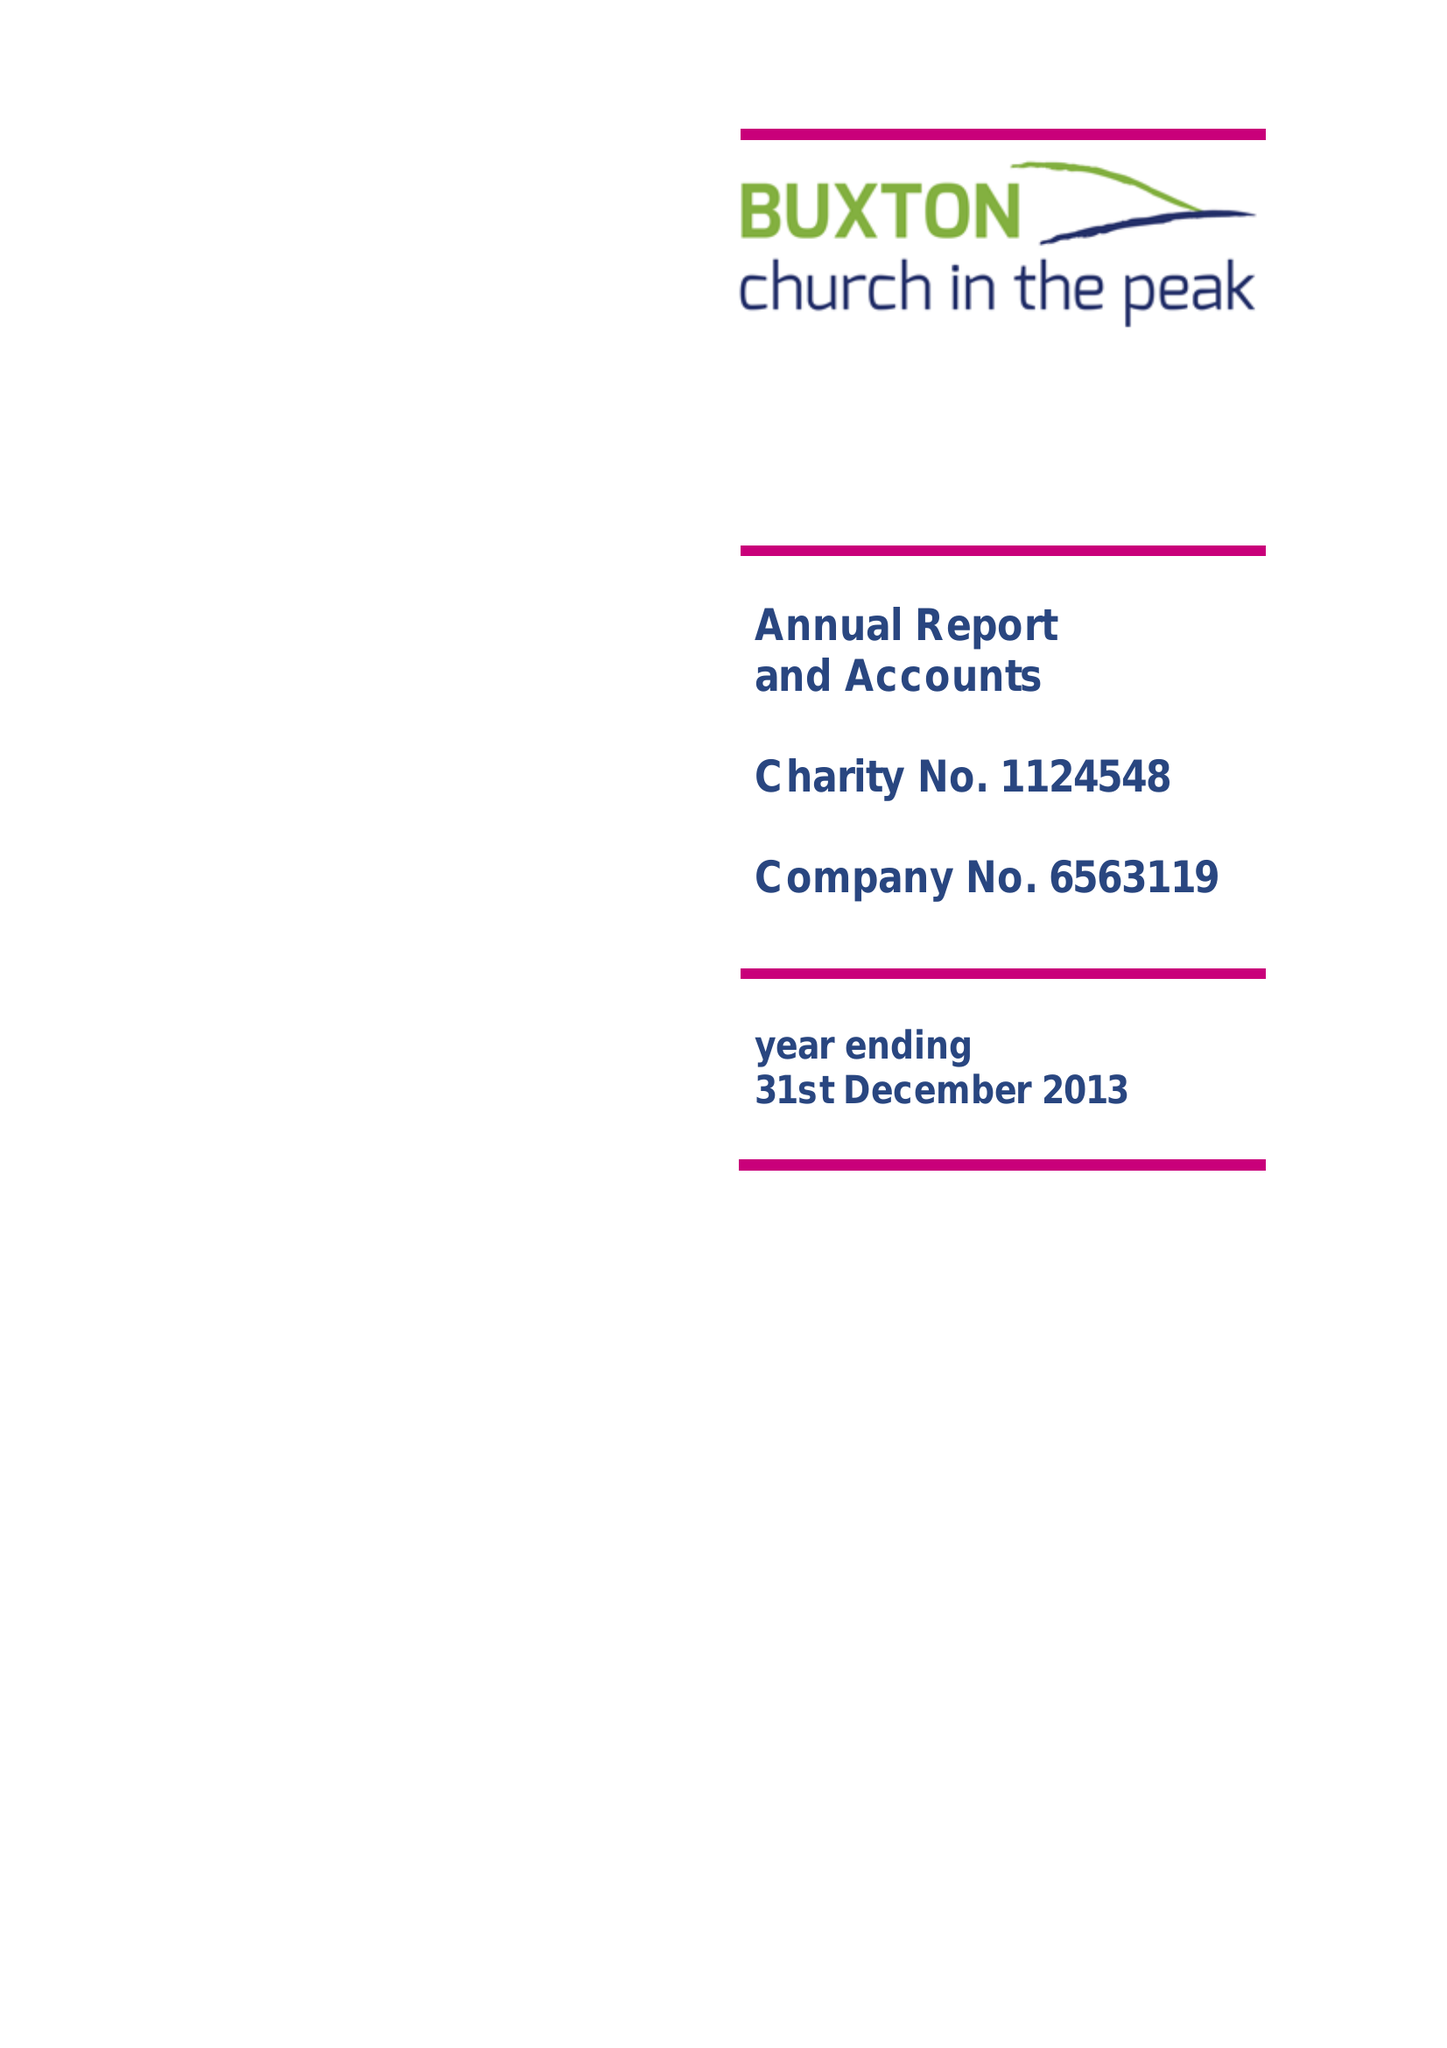What is the value for the income_annually_in_british_pounds?
Answer the question using a single word or phrase. 114793.00 